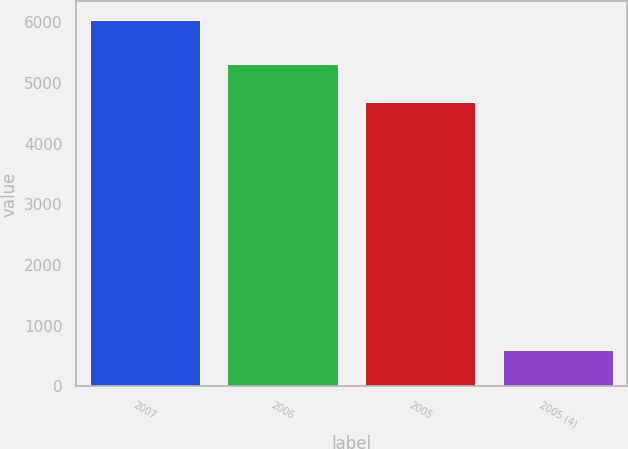Convert chart. <chart><loc_0><loc_0><loc_500><loc_500><bar_chart><fcel>2007<fcel>2006<fcel>2005<fcel>2005 (4)<nl><fcel>6043<fcel>5306<fcel>4680<fcel>604<nl></chart> 